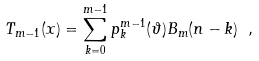<formula> <loc_0><loc_0><loc_500><loc_500>T _ { m - 1 } ( x ) = \sum ^ { m - 1 } _ { k = 0 } p ^ { m - 1 } _ { k } ( \vartheta ) B _ { m } ( n - k ) \ ,</formula> 